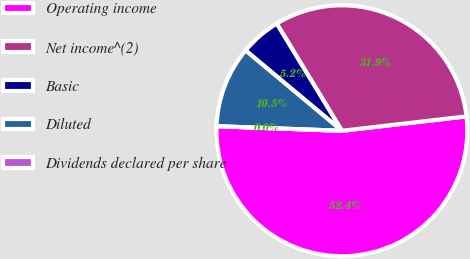Convert chart to OTSL. <chart><loc_0><loc_0><loc_500><loc_500><pie_chart><fcel>Operating income<fcel>Net income^(2)<fcel>Basic<fcel>Diluted<fcel>Dividends declared per share<nl><fcel>52.42%<fcel>31.86%<fcel>5.24%<fcel>10.48%<fcel>0.0%<nl></chart> 